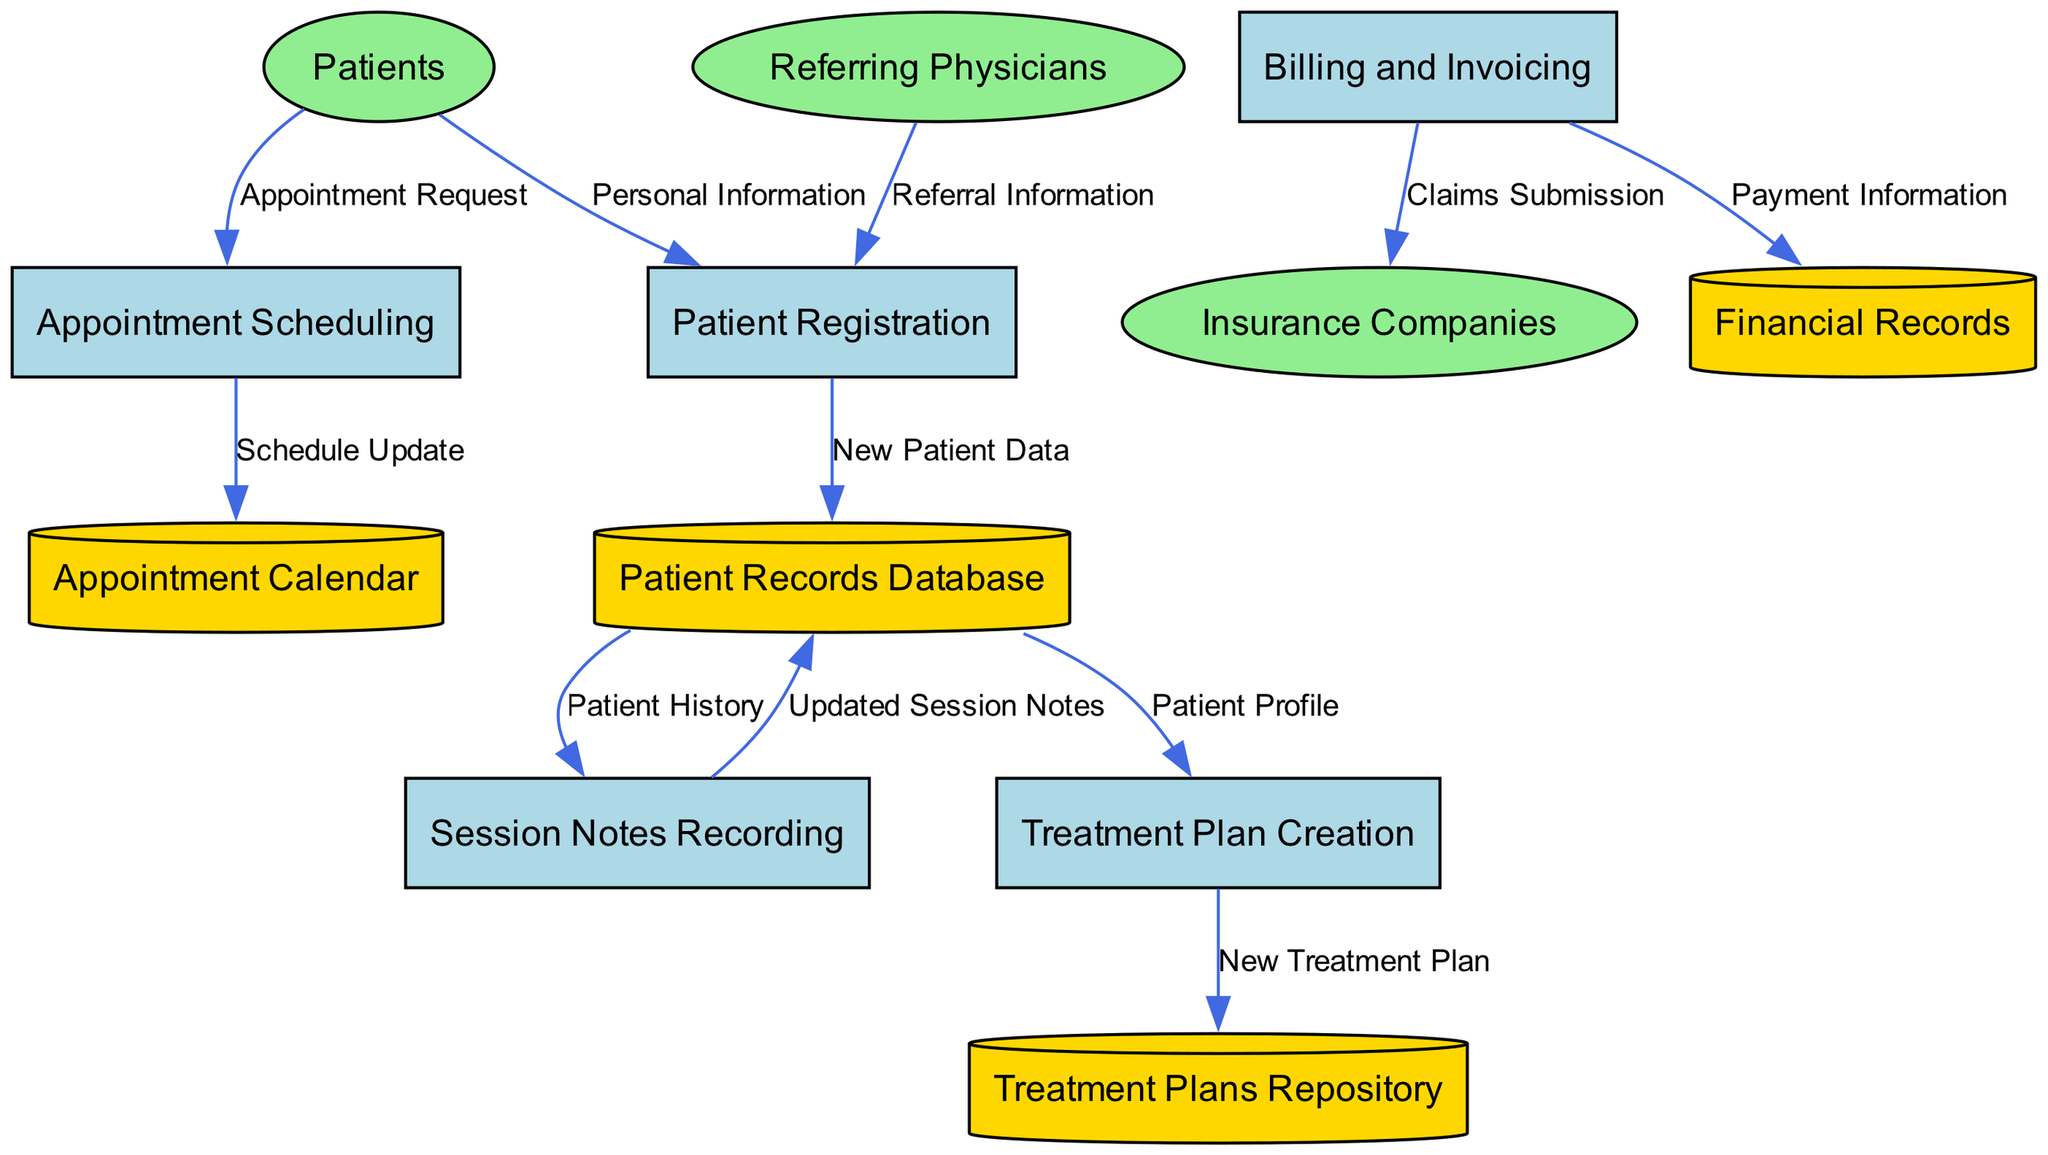What are the external entities involved in the system? The external entities in the diagram are Patients, Insurance Companies, and Referring Physicians. These entities are represented as ellipses in the diagram.
Answer: Patients, Insurance Companies, Referring Physicians How many processes are defined in the diagram? There are five processes listed in the diagram: Patient Registration, Appointment Scheduling, Session Notes Recording, Billing and Invoicing, and Treatment Plan Creation. Counting these gives us a total of five.
Answer: 5 Which process receives "Personal Information" from Patients? The data flow indicates that "Personal Information" flows from Patients to Patient Registration, indicating that this process is the one that receives such information.
Answer: Patient Registration What type of data is sent from Session Notes Recording to Patient Records Database? The data flow indicates that the type of data being sent from Session Notes Recording to Patient Records Database is labeled "Updated Session Notes." This specifies what is transferred in that flow.
Answer: Updated Session Notes Which process is responsible for submitting claims to Insurance Companies? The Billing and Invoicing process is responsible for sending "Claims Submission" to Insurance Companies, as per the data flow shown in the diagram.
Answer: Billing and Invoicing How many data stores are included in the diagram? The diagram shows four data stores: Patient Records Database, Appointment Calendar, Financial Records, and Treatment Plans Repository. Counting these yields a total of four data stores.
Answer: 4 What task occurs after the Appointment Scheduling process updates the Appointment Calendar? According to the diagram, after the Appointment Scheduling process sends a "Schedule Update," it connects to the Appointment Calendar, indicating that this is the task that occurs following the update.
Answer: Appointment Calendar From which external entity does the Patient Registration process receive data? The Patient Registration process receives data labeled "Referral Information" from the external entity Referring Physicians. This is indicated by the data flow in the diagram.
Answer: Referring Physicians Which data store is updated with new treatment plans? The Treatment Plans Repository is the data store that receives "New Treatment Plan" from the Treatment Plan Creation process, as represented by the flow in the diagram.
Answer: Treatment Plans Repository 